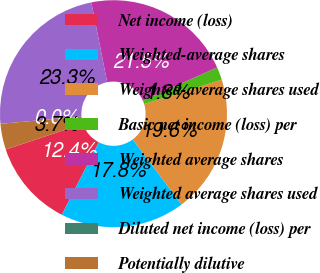Convert chart to OTSL. <chart><loc_0><loc_0><loc_500><loc_500><pie_chart><fcel>Net income (loss)<fcel>Weighted-average shares<fcel>Weighted-average shares used<fcel>Basic net income (loss) per<fcel>Weighted average shares<fcel>Weighted average shares used<fcel>Diluted net income (loss) per<fcel>Potentially dilutive<nl><fcel>12.37%<fcel>17.76%<fcel>19.6%<fcel>1.84%<fcel>21.45%<fcel>23.29%<fcel>0.0%<fcel>3.69%<nl></chart> 